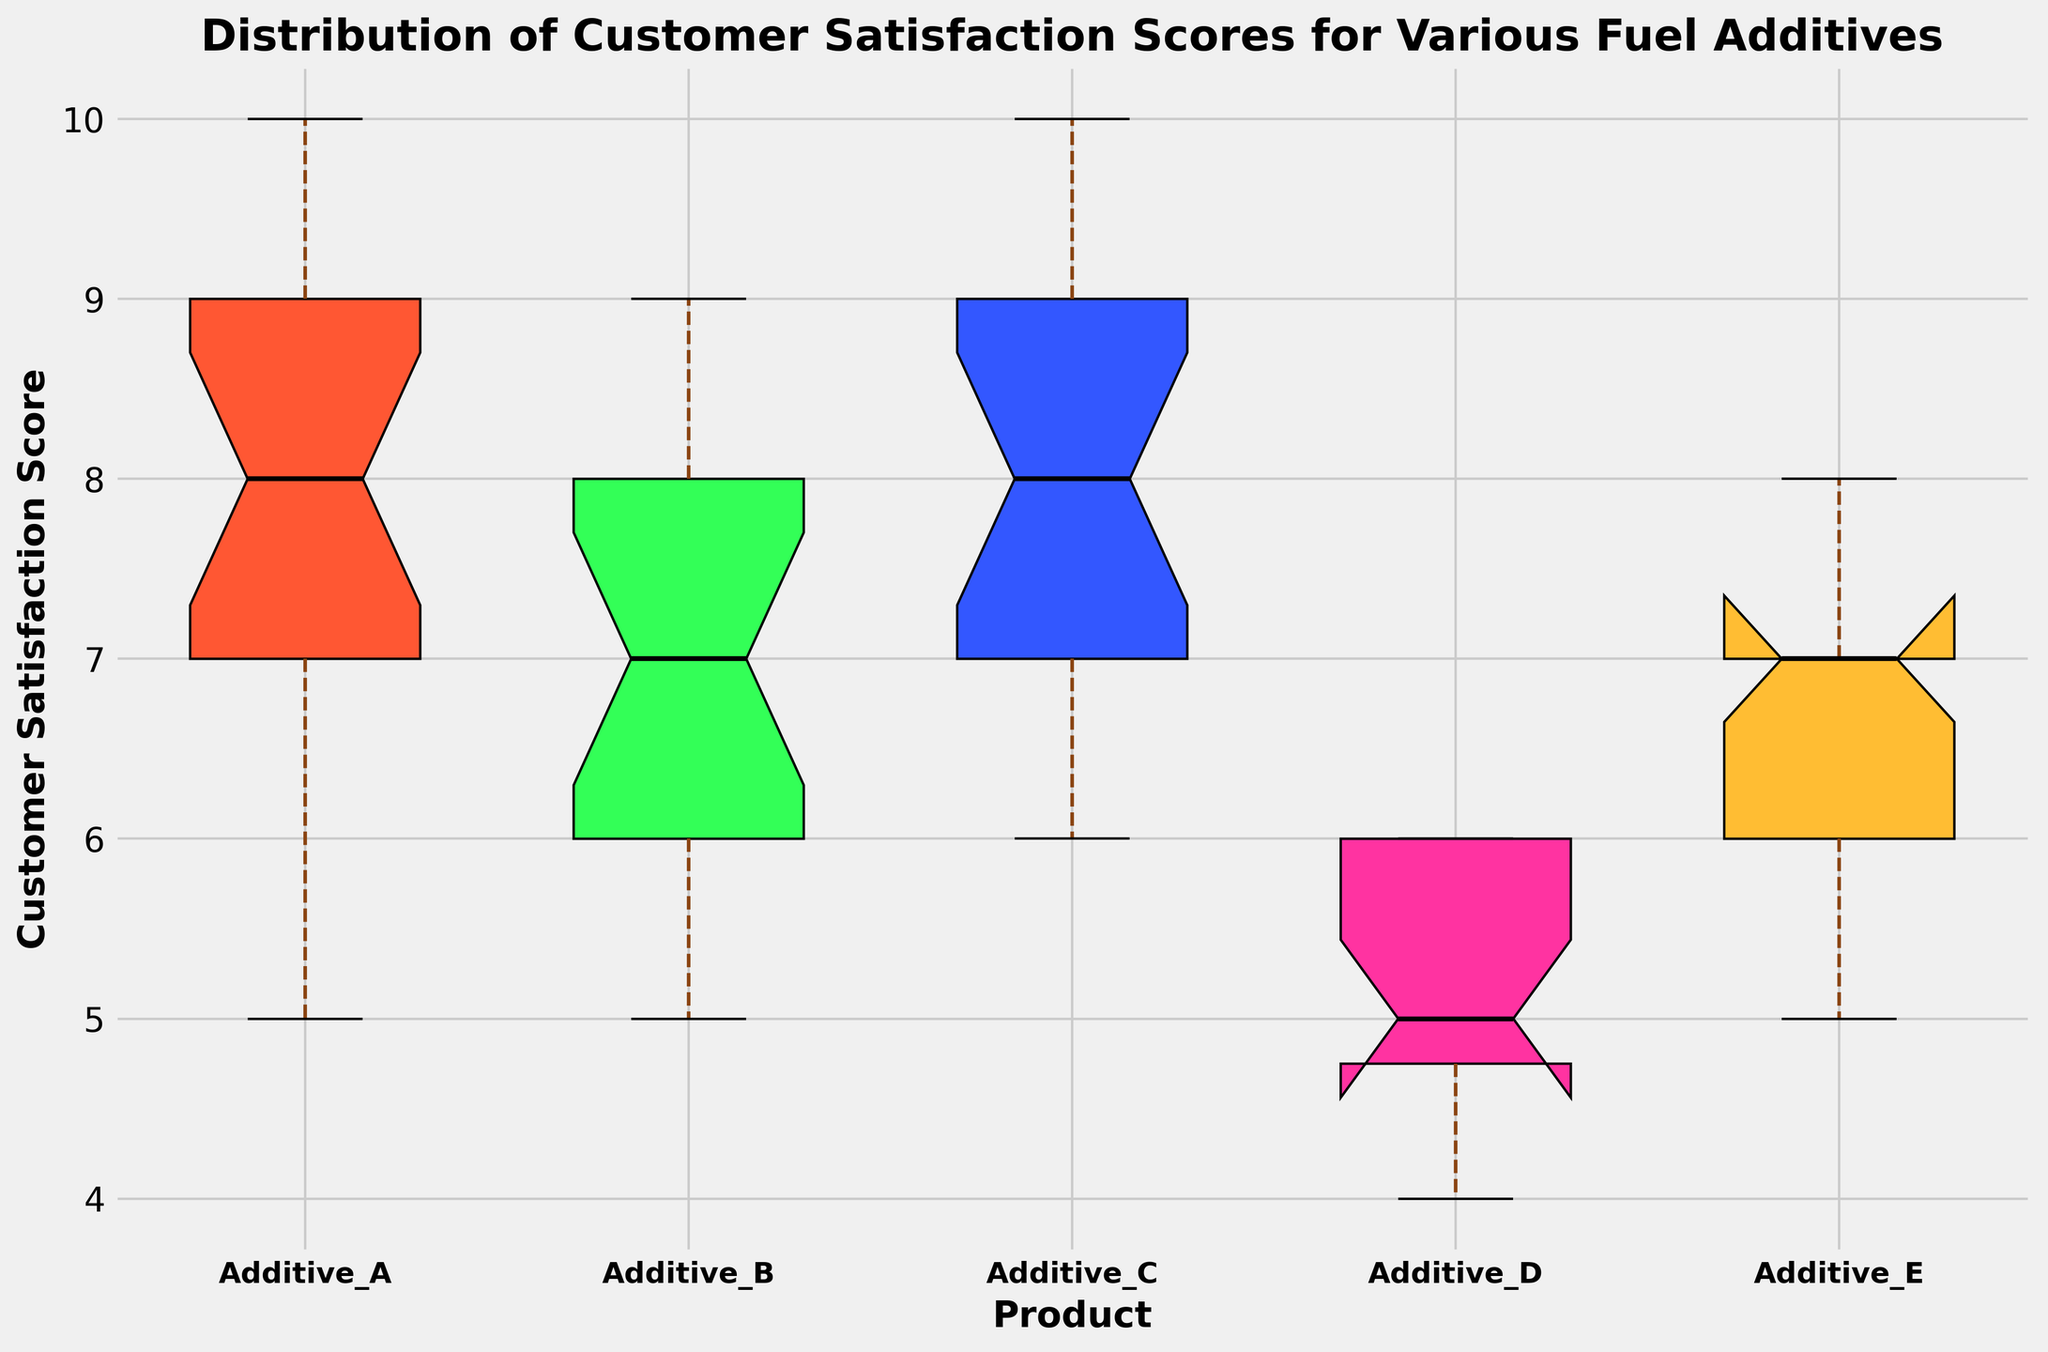what's the median score for Additive_A? To find the median score for Additive_A, look at the box plot for Additive_A. The median is indicated by the thick middle line inside the box.
Answer: 8 Which additive has the highest median score? To determine which additive has the highest median score, compare the thick middle lines inside the boxes for each additive.
Answer: Additive_C Which additive exhibits the most variability in customer satisfaction scores? Variability in scores can be assessed by the length of the box and whiskers. The longer they are, the higher the variability.
Answer: Additive_A How does the interquartile range (IQR) of Additive_D compare to Additive_E? The IQR is the length of the box in the box plot. Compare the lengths of the boxes for Additive_D and Additive_E. The IQR for Additive_E is broader than for Additive_D.
Answer: Additive_E has a larger IQR Are there any outliers in the dataset? If so, which additive(s) have them? Outliers are shown as individual points outside the whiskers. Examine the ends of the whiskers for any points. None of the additives have obvious outliers in this plot.
Answer: No outliers Which additive has the smallest range of customer satisfaction scores? To find the smallest range, look at the total length from the bottom whisker to the top whisker for each additive. Additive_D has the smallest range.
Answer: Additive_D What is the difference between the medians of Additive_B and Additive_E? Look at the median lines inside the boxes for Additive_B and Additive_E. Subtract the median of Additive_E from the median of Additive_B. Both have the same median.
Answer: 0 Which additive shows the greatest difference between the lowest and highest customer satisfaction scores? The greatest difference is indicated by the total length from the bottom whisker to the top whisker. Additive_A shows the greatest difference.
Answer: Additive_A 